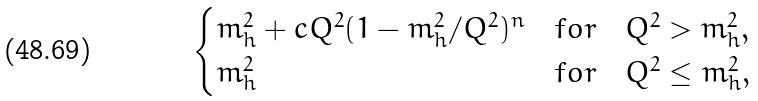<formula> <loc_0><loc_0><loc_500><loc_500>\begin{cases} m _ { h } ^ { 2 } + c Q ^ { 2 } ( 1 - m _ { h } ^ { 2 } / Q ^ { 2 } ) ^ { n } & f o r \quad Q ^ { 2 } > m _ { h } ^ { 2 } , \\ m _ { h } ^ { 2 } & f o r \quad Q ^ { 2 } \leq m _ { h } ^ { 2 } , \end{cases}</formula> 